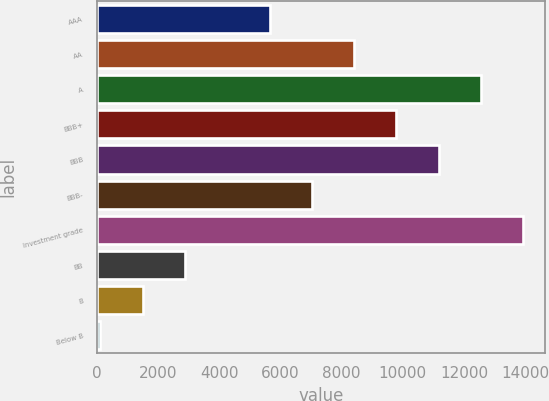Convert chart. <chart><loc_0><loc_0><loc_500><loc_500><bar_chart><fcel>AAA<fcel>AA<fcel>A<fcel>BBB+<fcel>BBB<fcel>BBB-<fcel>Investment grade<fcel>BB<fcel>B<fcel>Below B<nl><fcel>5641.4<fcel>8408.6<fcel>12559.4<fcel>9792.2<fcel>11175.8<fcel>7025<fcel>13943<fcel>2874.2<fcel>1490.6<fcel>107<nl></chart> 